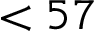<formula> <loc_0><loc_0><loc_500><loc_500>< 5 7</formula> 